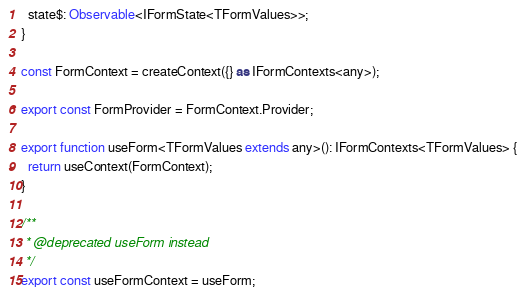Convert code to text. <code><loc_0><loc_0><loc_500><loc_500><_TypeScript_>  state$: Observable<IFormState<TFormValues>>;
}

const FormContext = createContext({} as IFormContexts<any>);

export const FormProvider = FormContext.Provider;

export function useForm<TFormValues extends any>(): IFormContexts<TFormValues> {
  return useContext(FormContext);
}

/**
 * @deprecated useForm instead
 */
export const useFormContext = useForm;
</code> 